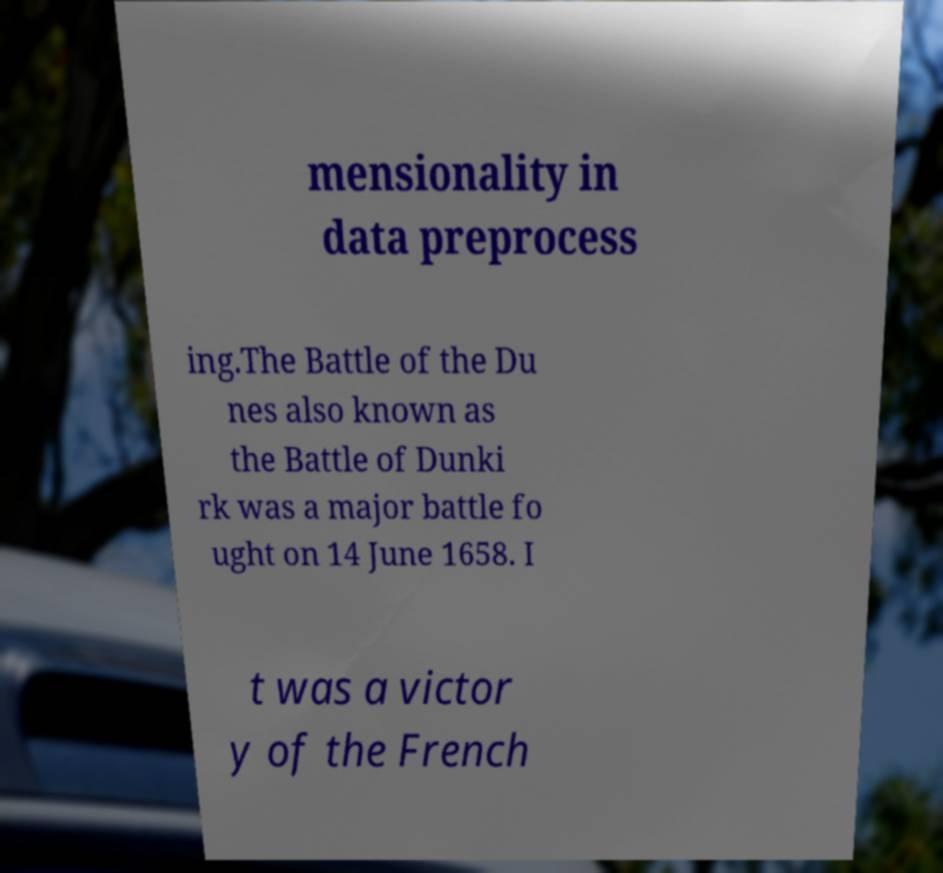Can you read and provide the text displayed in the image?This photo seems to have some interesting text. Can you extract and type it out for me? mensionality in data preprocess ing.The Battle of the Du nes also known as the Battle of Dunki rk was a major battle fo ught on 14 June 1658. I t was a victor y of the French 